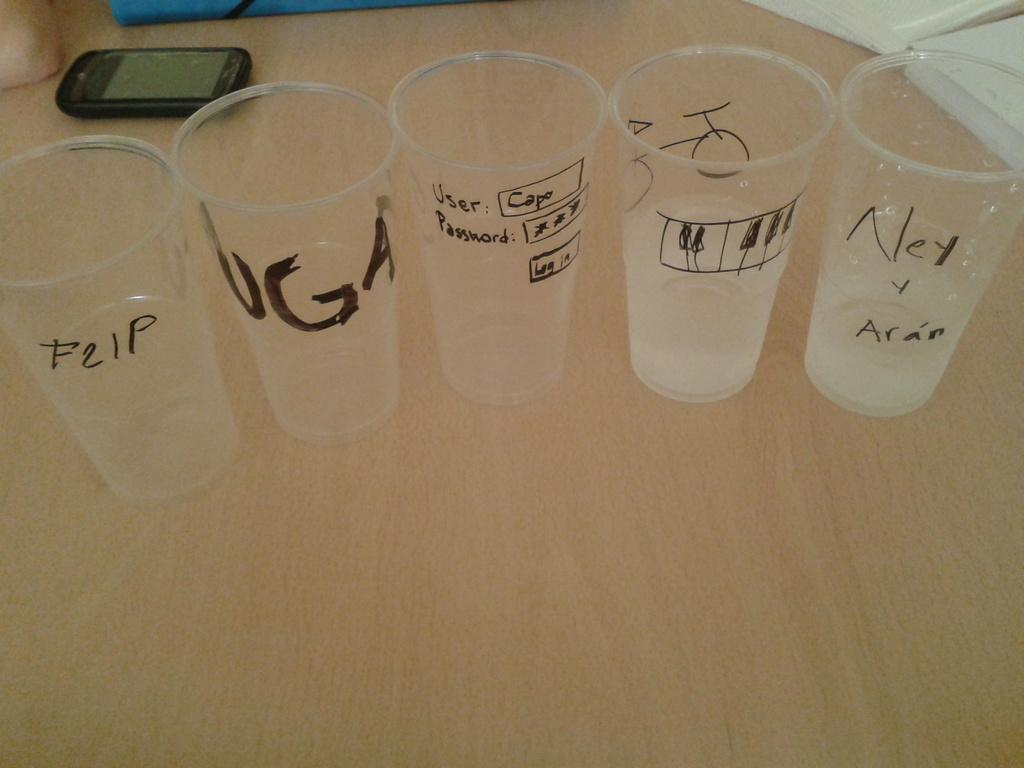Provide a one-sentence caption for the provided image. A clear cup that has "F21p" written on it in black marker sits on a table near several other clear cups with writing on them. 